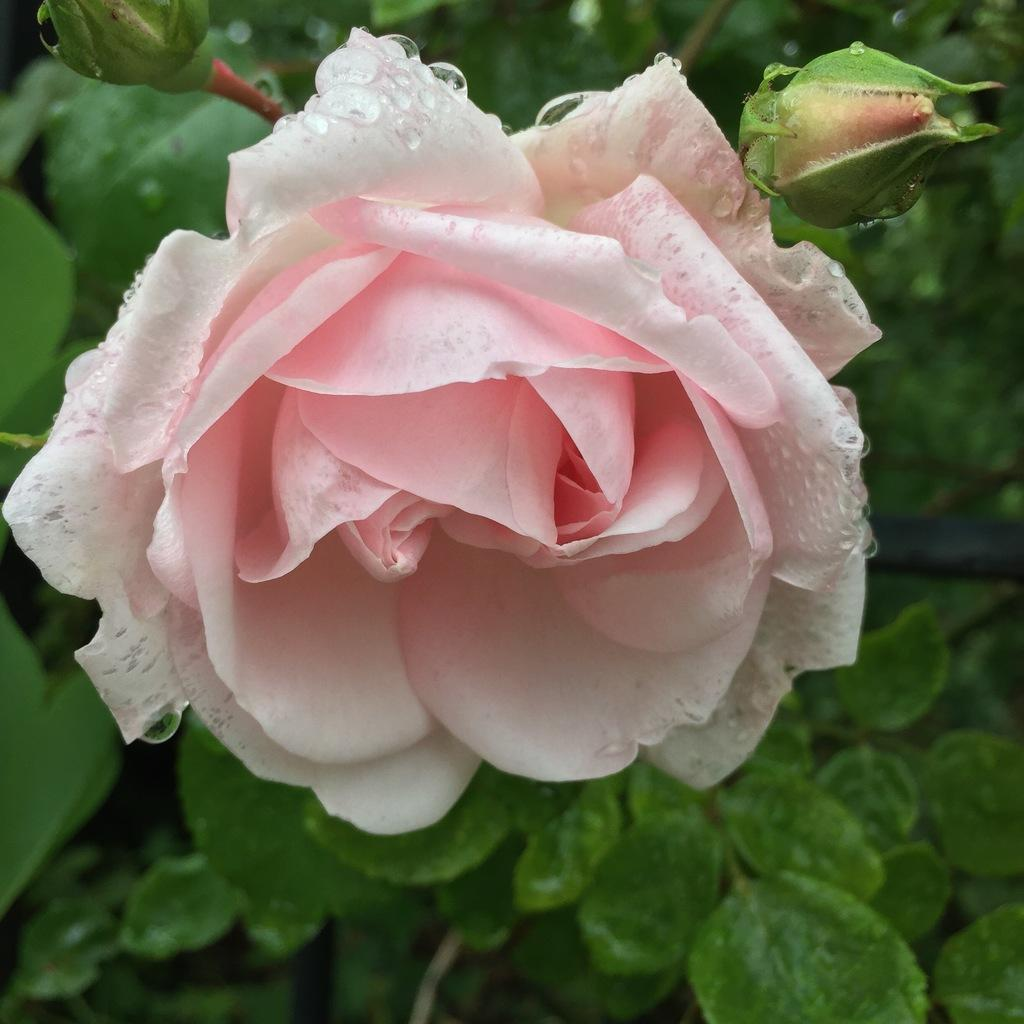What type of flower is in the image? There is a light pink rose flower in the image. Are there any unopened flowers in the image? Yes, there are a few buds in the image. What color are the leaves in the background of the image? The leaves in the background of the image are green. How does the flower contribute to pollution in the image? The flower does not contribute to pollution in the image; it is a natural element and does not produce any pollutants. 